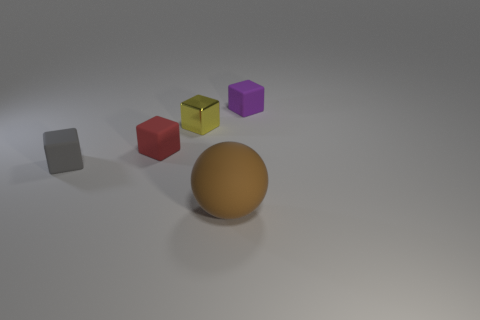Does the purple rubber block have the same size as the brown matte sphere?
Offer a very short reply. No. What is the size of the brown sphere that is the same material as the gray thing?
Provide a succinct answer. Large. Are there fewer purple matte cubes right of the purple block than big objects to the left of the tiny shiny object?
Offer a very short reply. No. Is the shape of the tiny rubber object that is to the left of the tiny red block the same as  the metallic object?
Offer a very short reply. Yes. Is there anything else that has the same material as the small gray thing?
Provide a succinct answer. Yes. Is the thing that is in front of the gray thing made of the same material as the small gray block?
Ensure brevity in your answer.  Yes. What is the material of the tiny gray cube that is on the left side of the thing in front of the gray rubber block on the left side of the yellow metallic thing?
Your answer should be very brief. Rubber. What number of other things are the same shape as the tiny metal object?
Your answer should be compact. 3. The matte object that is right of the brown matte thing is what color?
Offer a terse response. Purple. There is a matte thing in front of the tiny block in front of the small red rubber block; how many purple matte objects are to the left of it?
Provide a succinct answer. 0. 